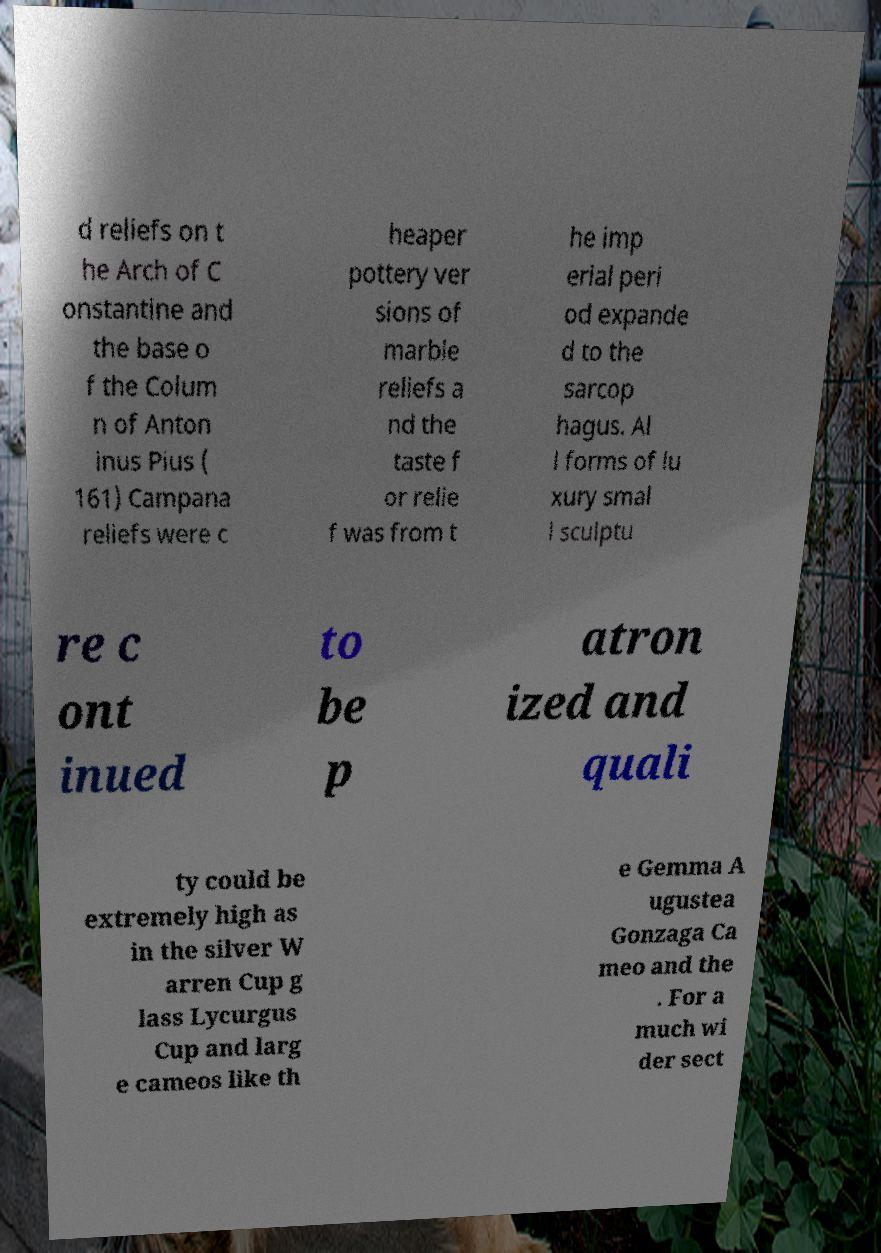Can you read and provide the text displayed in the image?This photo seems to have some interesting text. Can you extract and type it out for me? d reliefs on t he Arch of C onstantine and the base o f the Colum n of Anton inus Pius ( 161) Campana reliefs were c heaper pottery ver sions of marble reliefs a nd the taste f or relie f was from t he imp erial peri od expande d to the sarcop hagus. Al l forms of lu xury smal l sculptu re c ont inued to be p atron ized and quali ty could be extremely high as in the silver W arren Cup g lass Lycurgus Cup and larg e cameos like th e Gemma A ugustea Gonzaga Ca meo and the . For a much wi der sect 